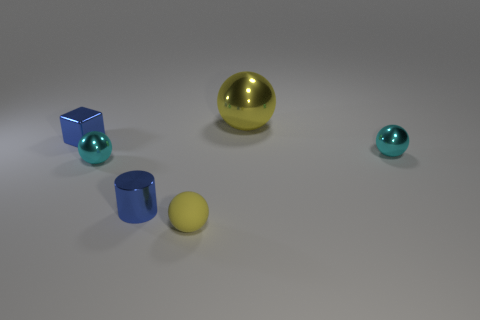There is a small yellow object that is the same shape as the large yellow thing; what is it made of?
Make the answer very short. Rubber. The cyan sphere that is to the left of the yellow object that is in front of the tiny shiny cube is made of what material?
Provide a succinct answer. Metal. Is the shape of the small yellow rubber object the same as the yellow object that is behind the tiny blue metal cylinder?
Offer a terse response. Yes. What number of metal objects are either blue cubes or big brown things?
Offer a terse response. 1. What is the color of the small metallic object that is in front of the shiny ball that is in front of the tiny cyan sphere on the right side of the large yellow sphere?
Ensure brevity in your answer.  Blue. How many other objects are there of the same material as the cylinder?
Offer a very short reply. 4. Does the blue object that is behind the blue cylinder have the same shape as the large shiny object?
Your answer should be very brief. No. How many small things are either blue cubes or green rubber cylinders?
Offer a terse response. 1. Are there an equal number of big yellow objects that are left of the tiny blue shiny cylinder and tiny blue shiny blocks that are to the right of the block?
Give a very brief answer. Yes. What number of other objects are the same color as the large metallic ball?
Make the answer very short. 1. 